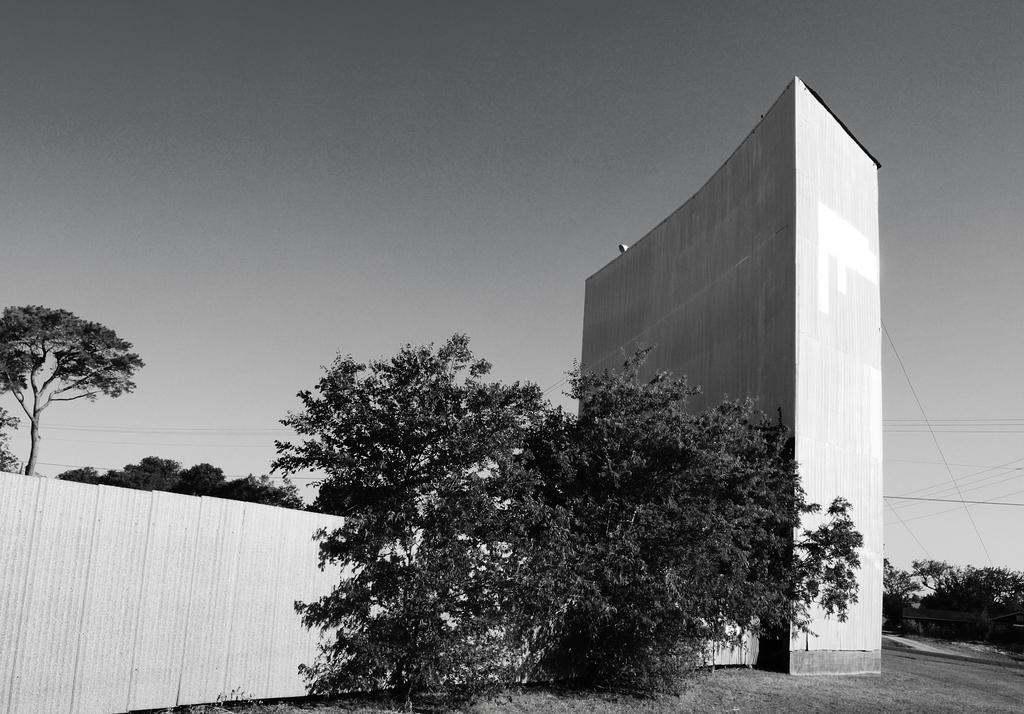What type of vegetation can be seen in the image? There are trees in the image. What material is used to construct the wall in the image? The wall in the image is made of wood. Can you describe the wall that is not made of wood? There is another wall in the image that is not made of wood. What can be seen in the background of the image? The sky is visible in the background of the image. What type of bubble is floating near the wooden wall in the image? There is no bubble present in the image. What mint-related object can be seen in the image? There is no mint-related object present in the image. 